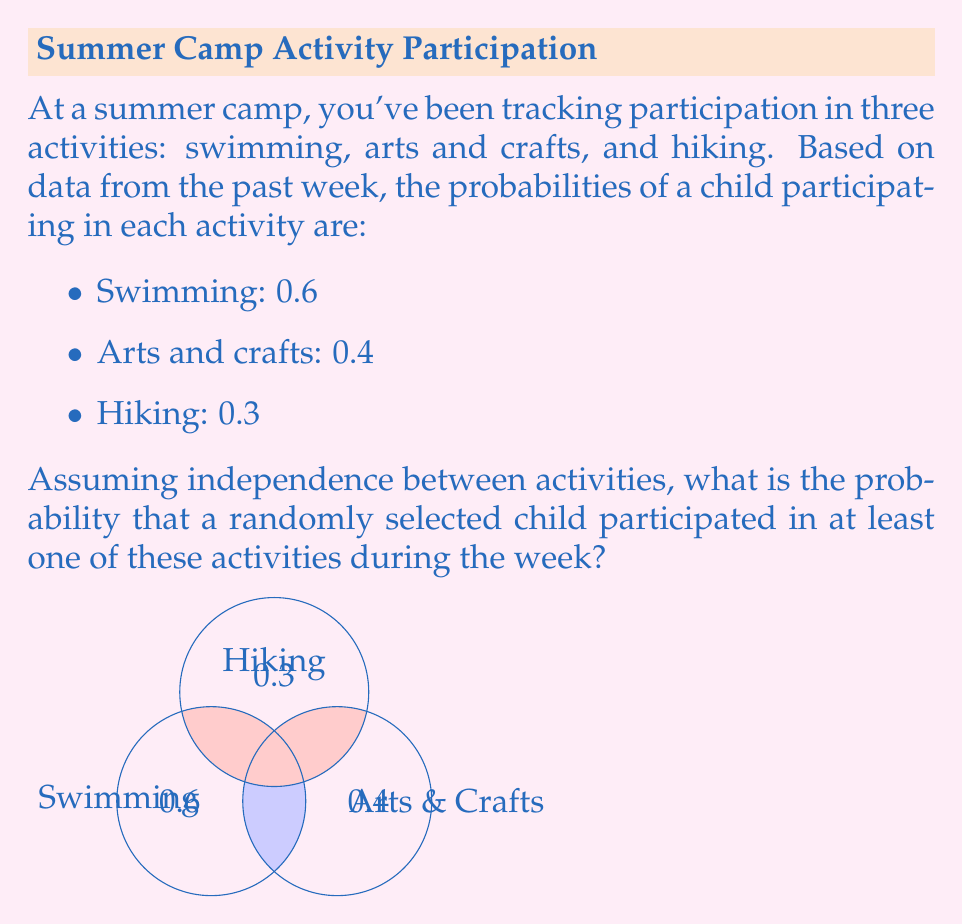Give your solution to this math problem. To solve this problem, we'll use the complement of the probability that a child participated in none of the activities. Let's approach this step-by-step:

1) First, let's calculate the probability that a child did not participate in each activity:
   - P(not swimming) = 1 - 0.6 = 0.4
   - P(not arts and crafts) = 1 - 0.4 = 0.6
   - P(not hiking) = 1 - 0.3 = 0.7

2) Since we assume independence, the probability of not participating in any activity is the product of these probabilities:

   $$P(\text{no activities}) = 0.4 \times 0.6 \times 0.7 = 0.168$$

3) The probability of participating in at least one activity is the complement of participating in no activities:

   $$P(\text{at least one activity}) = 1 - P(\text{no activities})$$
   $$= 1 - 0.168 = 0.832$$

4) Therefore, the probability that a randomly selected child participated in at least one of these activities during the week is 0.832 or 83.2%.
Answer: 0.832 